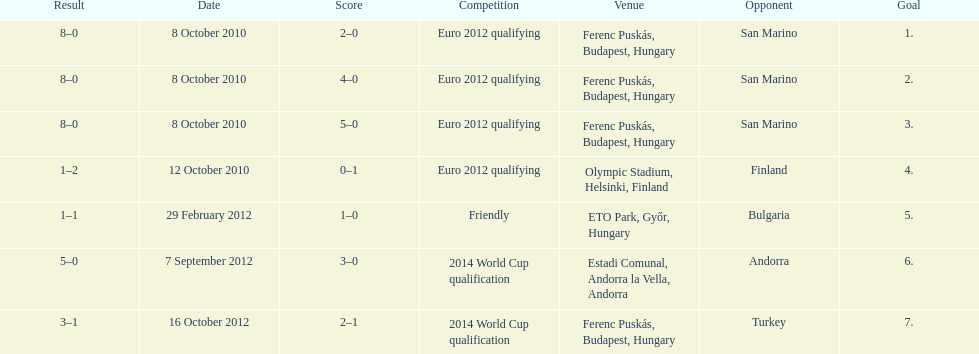What is the number of goals ádám szalai made against san marino in 2010? 3. 